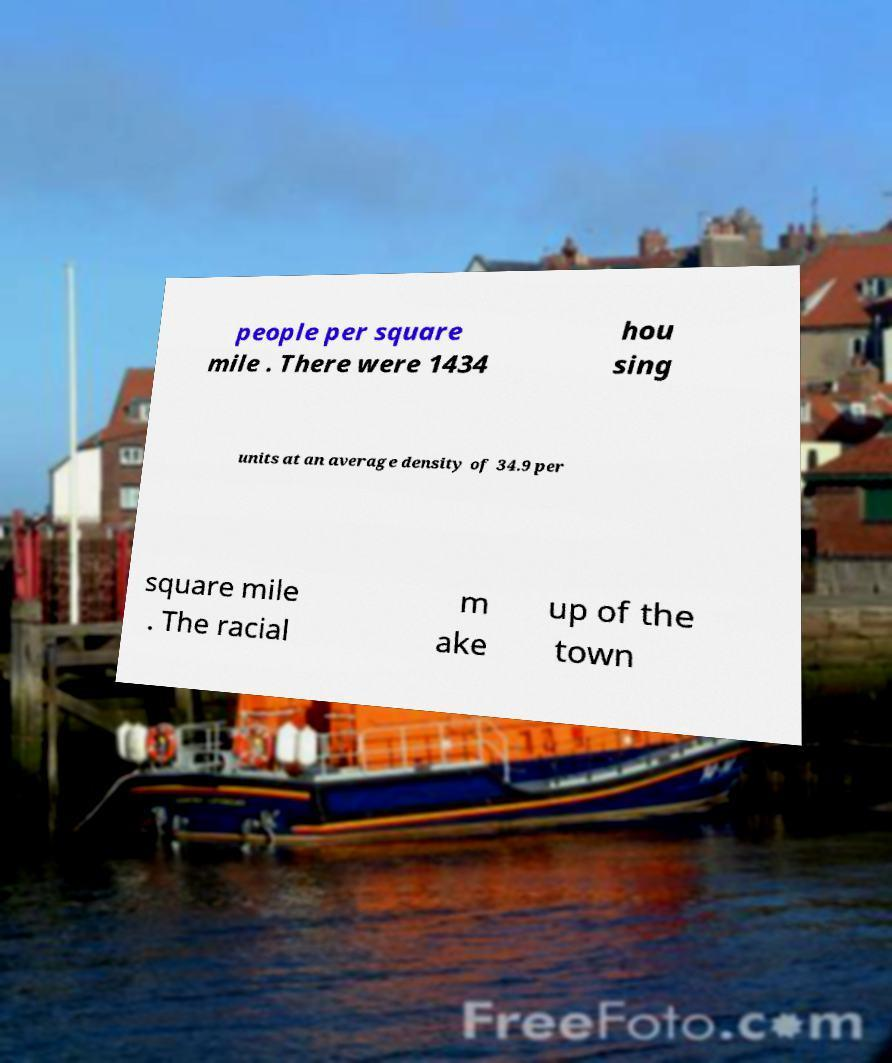Can you read and provide the text displayed in the image?This photo seems to have some interesting text. Can you extract and type it out for me? people per square mile . There were 1434 hou sing units at an average density of 34.9 per square mile . The racial m ake up of the town 